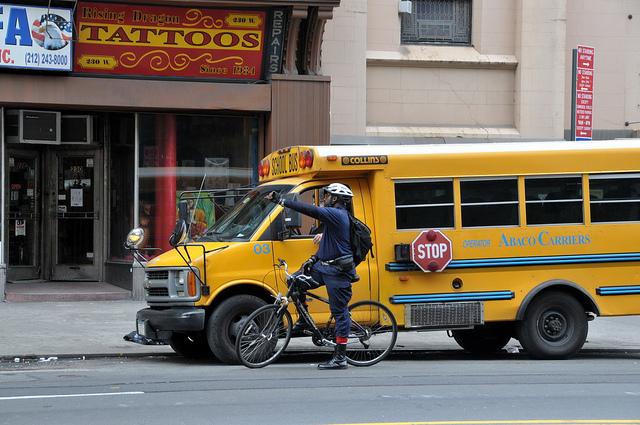What is the name of the tattoo parlor?
Give a very brief answer. Rising dragon. What is this person riding?
Be succinct. Bike. What is the name listed on the bus?
Short answer required. Abaco carriers. What store's parking lot is this?
Give a very brief answer. Tattoos. What kind of business is behind the bus?
Concise answer only. Tattoos. 